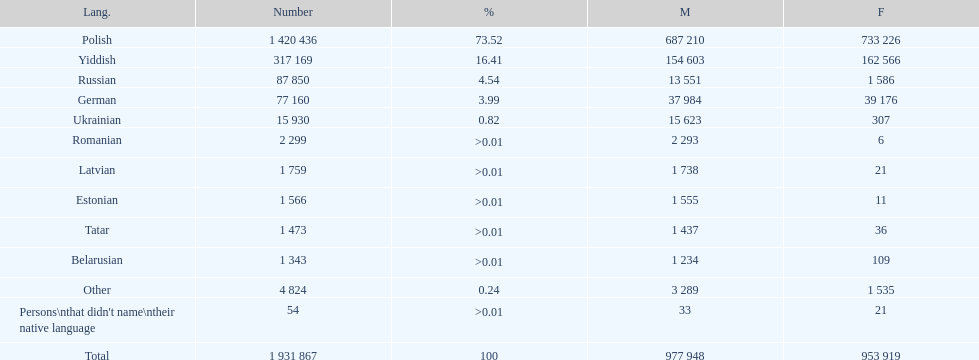What was the next most commonly spoken language in poland after russian? German. 